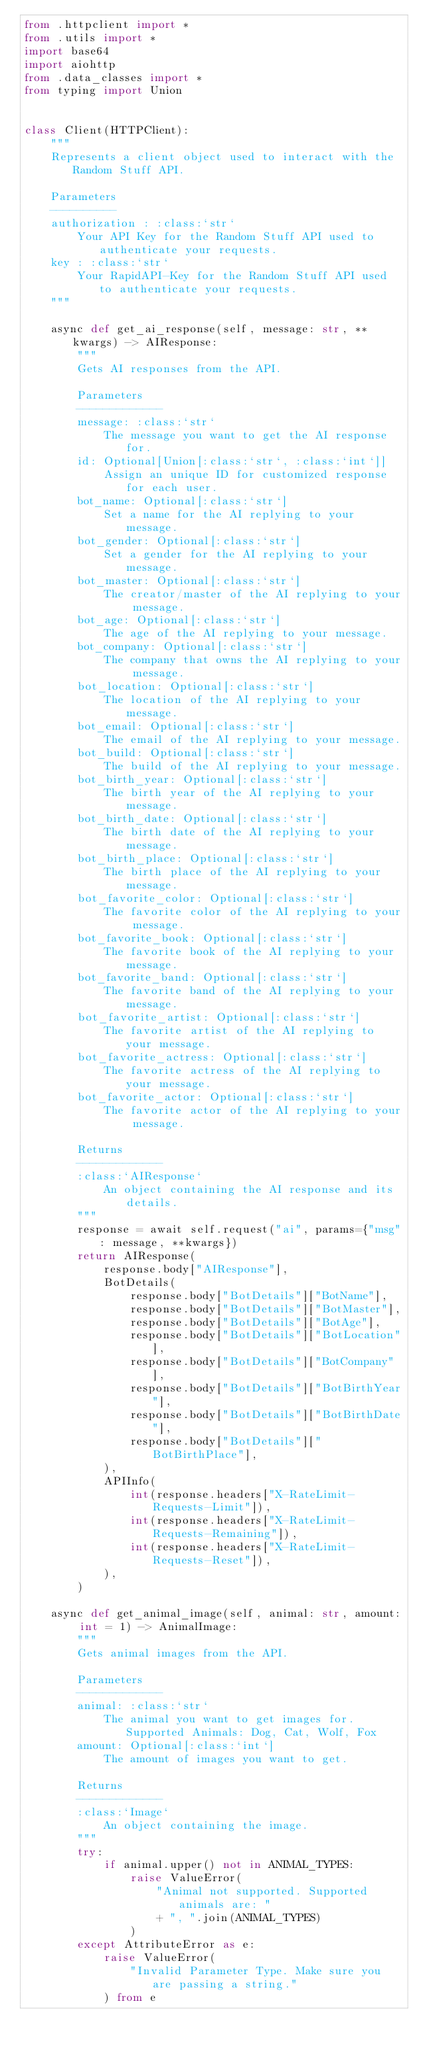Convert code to text. <code><loc_0><loc_0><loc_500><loc_500><_Python_>from .httpclient import *
from .utils import *
import base64
import aiohttp
from .data_classes import *
from typing import Union


class Client(HTTPClient):
    """
    Represents a client object used to interact with the Random Stuff API.

    Parameters
    ----------
    authorization : :class:`str`
        Your API Key for the Random Stuff API used to authenticate your requests.
    key : :class:`str`
        Your RapidAPI-Key for the Random Stuff API used to authenticate your requests.
    """

    async def get_ai_response(self, message: str, **kwargs) -> AIResponse:
        """
        Gets AI responses from the API.

        Parameters
        -------------
        message: :class:`str`
            The message you want to get the AI response for.
        id: Optional[Union[:class:`str`, :class:`int`]]
            Assign an unique ID for customized response for each user.
        bot_name: Optional[:class:`str`]
            Set a name for the AI replying to your message.
        bot_gender: Optional[:class:`str`]
            Set a gender for the AI replying to your message.
        bot_master: Optional[:class:`str`]
            The creator/master of the AI replying to your message.
        bot_age: Optional[:class:`str`]
            The age of the AI replying to your message.
        bot_company: Optional[:class:`str`]
            The company that owns the AI replying to your message.
        bot_location: Optional[:class:`str`]
            The location of the AI replying to your message.
        bot_email: Optional[:class:`str`]
            The email of the AI replying to your message.
        bot_build: Optional[:class:`str`]
            The build of the AI replying to your message.
        bot_birth_year: Optional[:class:`str`]
            The birth year of the AI replying to your message.
        bot_birth_date: Optional[:class:`str`]
            The birth date of the AI replying to your message.
        bot_birth_place: Optional[:class:`str`]
            The birth place of the AI replying to your message.
        bot_favorite_color: Optional[:class:`str`]
            The favorite color of the AI replying to your message.
        bot_favorite_book: Optional[:class:`str`]
            The favorite book of the AI replying to your message.
        bot_favorite_band: Optional[:class:`str`]
            The favorite band of the AI replying to your message.
        bot_favorite_artist: Optional[:class:`str`]
            The favorite artist of the AI replying to your message.
        bot_favorite_actress: Optional[:class:`str`]
            The favorite actress of the AI replying to your message.
        bot_favorite_actor: Optional[:class:`str`]
            The favorite actor of the AI replying to your message.

        Returns
        -------------
        :class:`AIResponse`
            An object containing the AI response and its details.
        """
        response = await self.request("ai", params={"msg": message, **kwargs})
        return AIResponse(
            response.body["AIResponse"],
            BotDetails(
                response.body["BotDetails"]["BotName"],
                response.body["BotDetails"]["BotMaster"],
                response.body["BotDetails"]["BotAge"],
                response.body["BotDetails"]["BotLocation"],
                response.body["BotDetails"]["BotCompany"],
                response.body["BotDetails"]["BotBirthYear"],
                response.body["BotDetails"]["BotBirthDate"],
                response.body["BotDetails"]["BotBirthPlace"],
            ),
            APIInfo(
                int(response.headers["X-RateLimit-Requests-Limit"]),
                int(response.headers["X-RateLimit-Requests-Remaining"]),
                int(response.headers["X-RateLimit-Requests-Reset"]),
            ),
        )

    async def get_animal_image(self, animal: str, amount: int = 1) -> AnimalImage:
        """
        Gets animal images from the API.

        Parameters
        -------------
        animal: :class:`str`
            The animal you want to get images for. Supported Animals: Dog, Cat, Wolf, Fox
        amount: Optional[:class:`int`]
            The amount of images you want to get.

        Returns
        -------------
        :class:`Image`
            An object containing the image.
        """
        try:
            if animal.upper() not in ANIMAL_TYPES:
                raise ValueError(
                    "Animal not supported. Supported animals are: "
                    + ", ".join(ANIMAL_TYPES)
                )
        except AttributeError as e:
            raise ValueError(
                "Invalid Parameter Type. Make sure you are passing a string."
            ) from e
</code> 